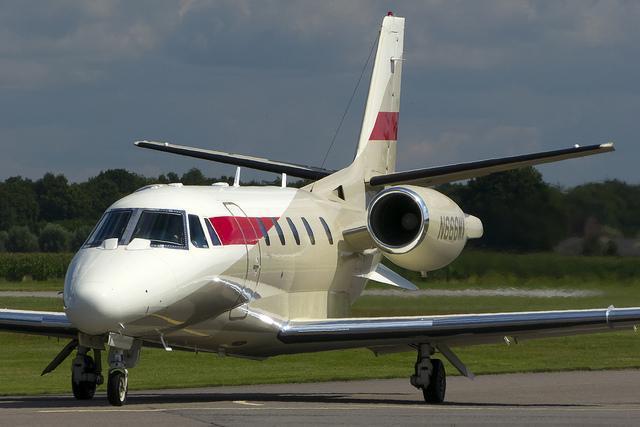How many jets does the plane have?
Give a very brief answer. 2. How many horses are there?
Give a very brief answer. 0. 